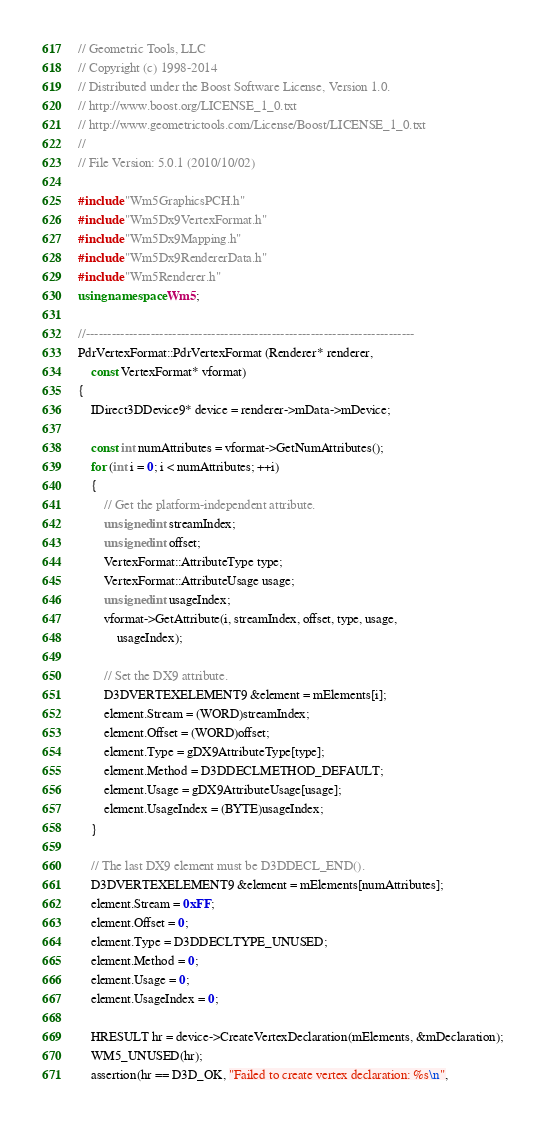Convert code to text. <code><loc_0><loc_0><loc_500><loc_500><_C++_>// Geometric Tools, LLC
// Copyright (c) 1998-2014
// Distributed under the Boost Software License, Version 1.0.
// http://www.boost.org/LICENSE_1_0.txt
// http://www.geometrictools.com/License/Boost/LICENSE_1_0.txt
//
// File Version: 5.0.1 (2010/10/02)

#include "Wm5GraphicsPCH.h"
#include "Wm5Dx9VertexFormat.h"
#include "Wm5Dx9Mapping.h"
#include "Wm5Dx9RendererData.h"
#include "Wm5Renderer.h"
using namespace Wm5;

//----------------------------------------------------------------------------
PdrVertexFormat::PdrVertexFormat (Renderer* renderer,
    const VertexFormat* vformat)
{
    IDirect3DDevice9* device = renderer->mData->mDevice;

    const int numAttributes = vformat->GetNumAttributes();
    for (int i = 0; i < numAttributes; ++i)
    {
        // Get the platform-independent attribute.
        unsigned int streamIndex;
        unsigned int offset;
        VertexFormat::AttributeType type;
        VertexFormat::AttributeUsage usage;
        unsigned int usageIndex;
        vformat->GetAttribute(i, streamIndex, offset, type, usage,
            usageIndex);

        // Set the DX9 attribute.
        D3DVERTEXELEMENT9 &element = mElements[i];
        element.Stream = (WORD)streamIndex;
        element.Offset = (WORD)offset;
        element.Type = gDX9AttributeType[type];
        element.Method = D3DDECLMETHOD_DEFAULT;
        element.Usage = gDX9AttributeUsage[usage];
        element.UsageIndex = (BYTE)usageIndex;
    }

    // The last DX9 element must be D3DDECL_END().
    D3DVERTEXELEMENT9 &element = mElements[numAttributes];
    element.Stream = 0xFF;
    element.Offset = 0;
    element.Type = D3DDECLTYPE_UNUSED;
    element.Method = 0;
    element.Usage = 0;
    element.UsageIndex = 0;

    HRESULT hr = device->CreateVertexDeclaration(mElements, &mDeclaration);
    WM5_UNUSED(hr);
    assertion(hr == D3D_OK, "Failed to create vertex declaration: %s\n",</code> 